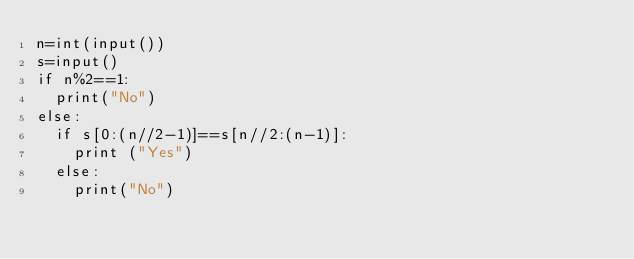Convert code to text. <code><loc_0><loc_0><loc_500><loc_500><_Python_>n=int(input())
s=input()
if n%2==1:
  print("No")
else:
  if s[0:(n//2-1)]==s[n//2:(n-1)]:
    print ("Yes")
  else:
    print("No")</code> 